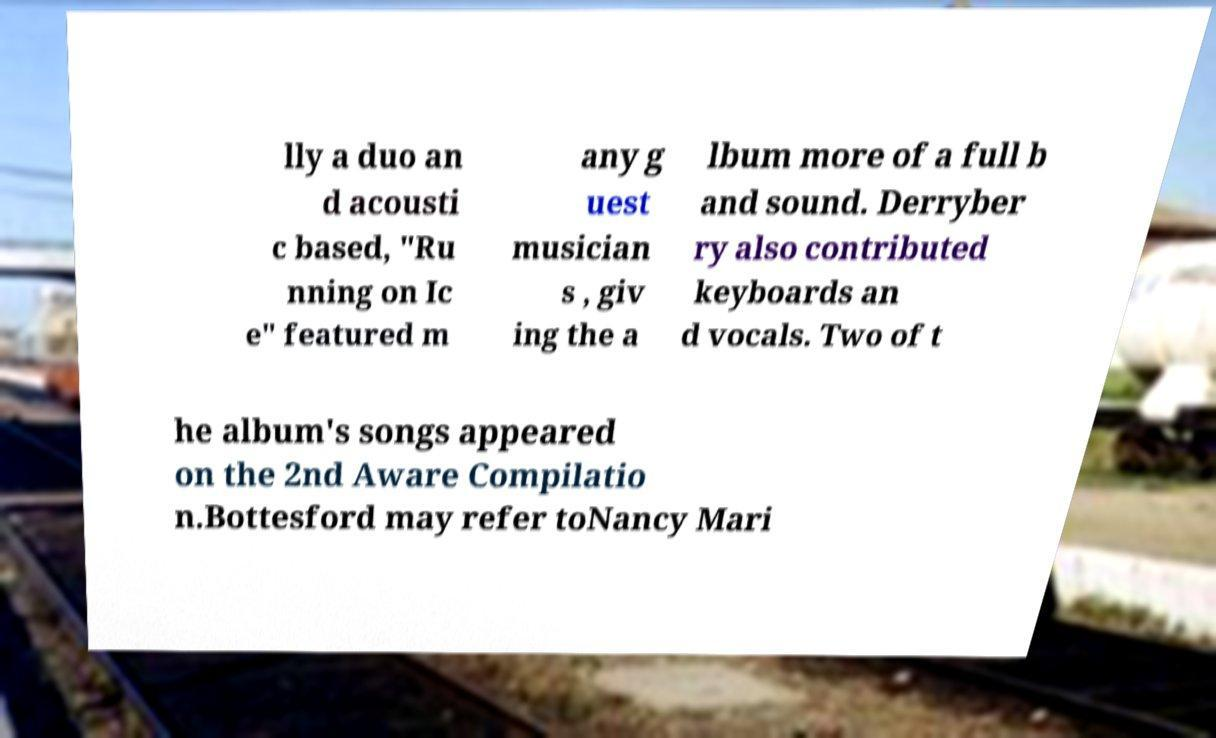For documentation purposes, I need the text within this image transcribed. Could you provide that? lly a duo an d acousti c based, "Ru nning on Ic e" featured m any g uest musician s , giv ing the a lbum more of a full b and sound. Derryber ry also contributed keyboards an d vocals. Two of t he album's songs appeared on the 2nd Aware Compilatio n.Bottesford may refer toNancy Mari 